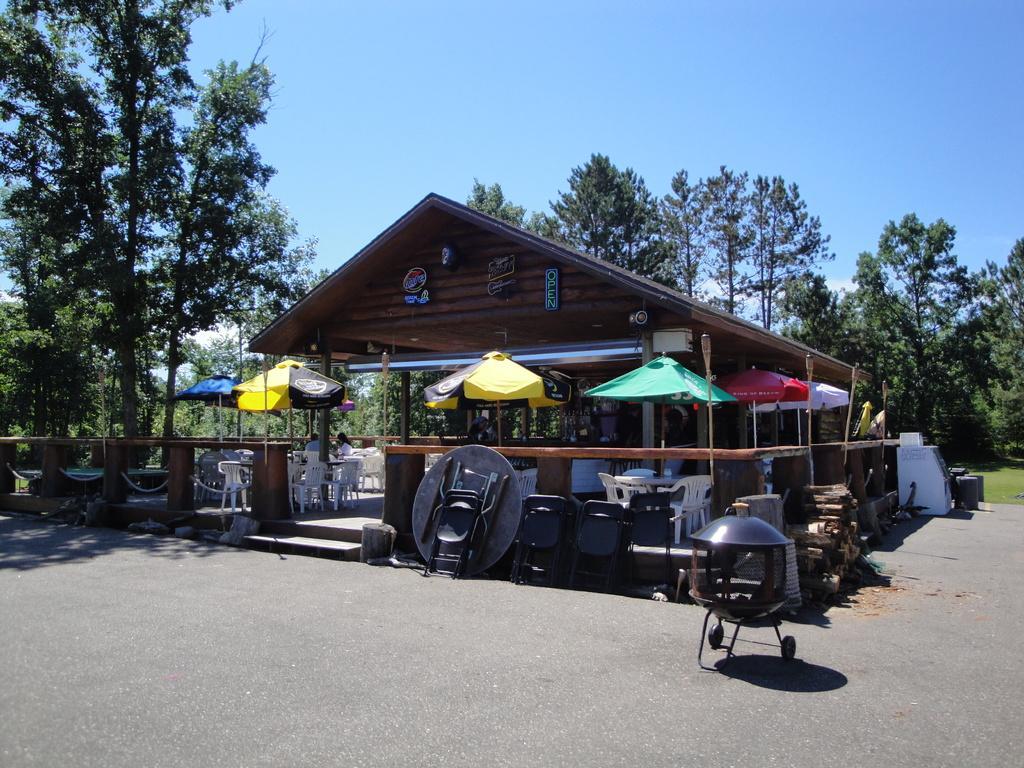Can you describe this image briefly? This picture is clicked outside. On the right there is an object placed on the ground. In the center we can see a cabin, umbrellas, lamp posts, chairs, some wooden objects and many other objects and we can see the text on the boards which are hanging on the wall of the cabin and we can see the group of people seems to be sitting on the chairs. In the background we can see the sky and the trees and the green grass. 